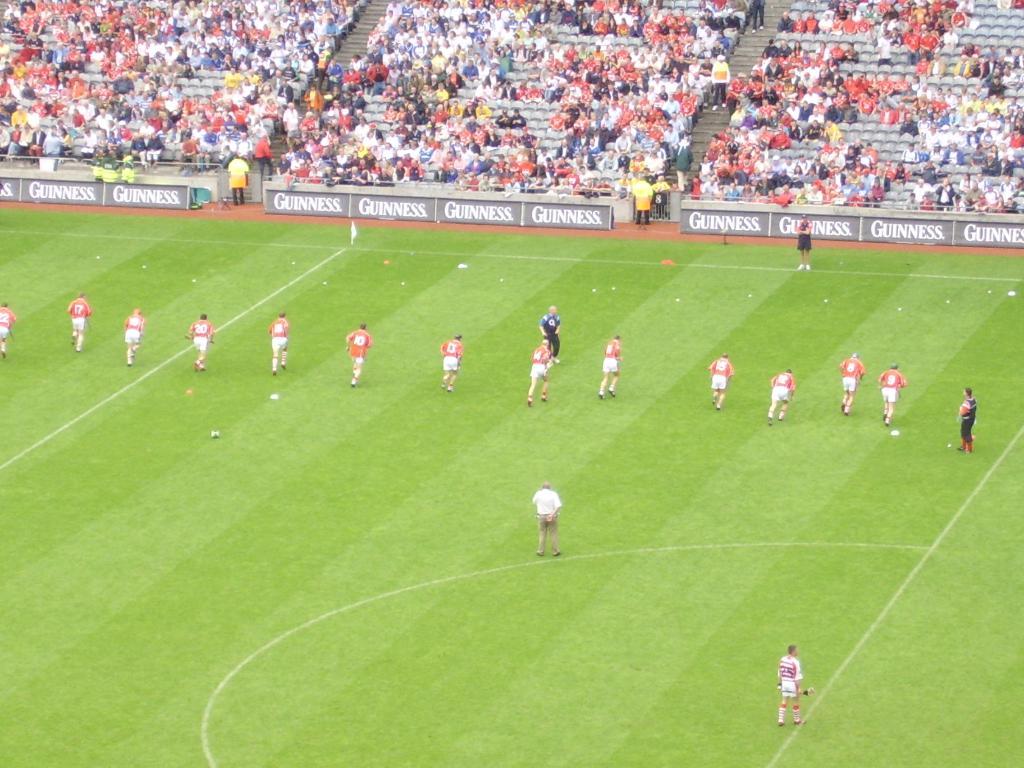Which company is advertising on the banners?
Offer a very short reply. Guinness. 